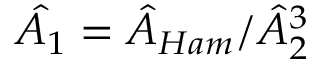Convert formula to latex. <formula><loc_0><loc_0><loc_500><loc_500>\hat { A _ { 1 } } = \hat { A } _ { H a m } / \hat { A } _ { 2 } ^ { 3 }</formula> 